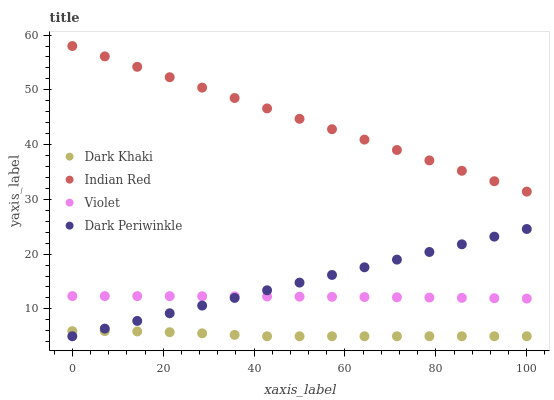Does Dark Khaki have the minimum area under the curve?
Answer yes or no. Yes. Does Indian Red have the maximum area under the curve?
Answer yes or no. Yes. Does Dark Periwinkle have the minimum area under the curve?
Answer yes or no. No. Does Dark Periwinkle have the maximum area under the curve?
Answer yes or no. No. Is Dark Periwinkle the smoothest?
Answer yes or no. Yes. Is Dark Khaki the roughest?
Answer yes or no. Yes. Is Indian Red the smoothest?
Answer yes or no. No. Is Indian Red the roughest?
Answer yes or no. No. Does Dark Khaki have the lowest value?
Answer yes or no. Yes. Does Indian Red have the lowest value?
Answer yes or no. No. Does Indian Red have the highest value?
Answer yes or no. Yes. Does Dark Periwinkle have the highest value?
Answer yes or no. No. Is Dark Periwinkle less than Indian Red?
Answer yes or no. Yes. Is Indian Red greater than Violet?
Answer yes or no. Yes. Does Dark Periwinkle intersect Violet?
Answer yes or no. Yes. Is Dark Periwinkle less than Violet?
Answer yes or no. No. Is Dark Periwinkle greater than Violet?
Answer yes or no. No. Does Dark Periwinkle intersect Indian Red?
Answer yes or no. No. 